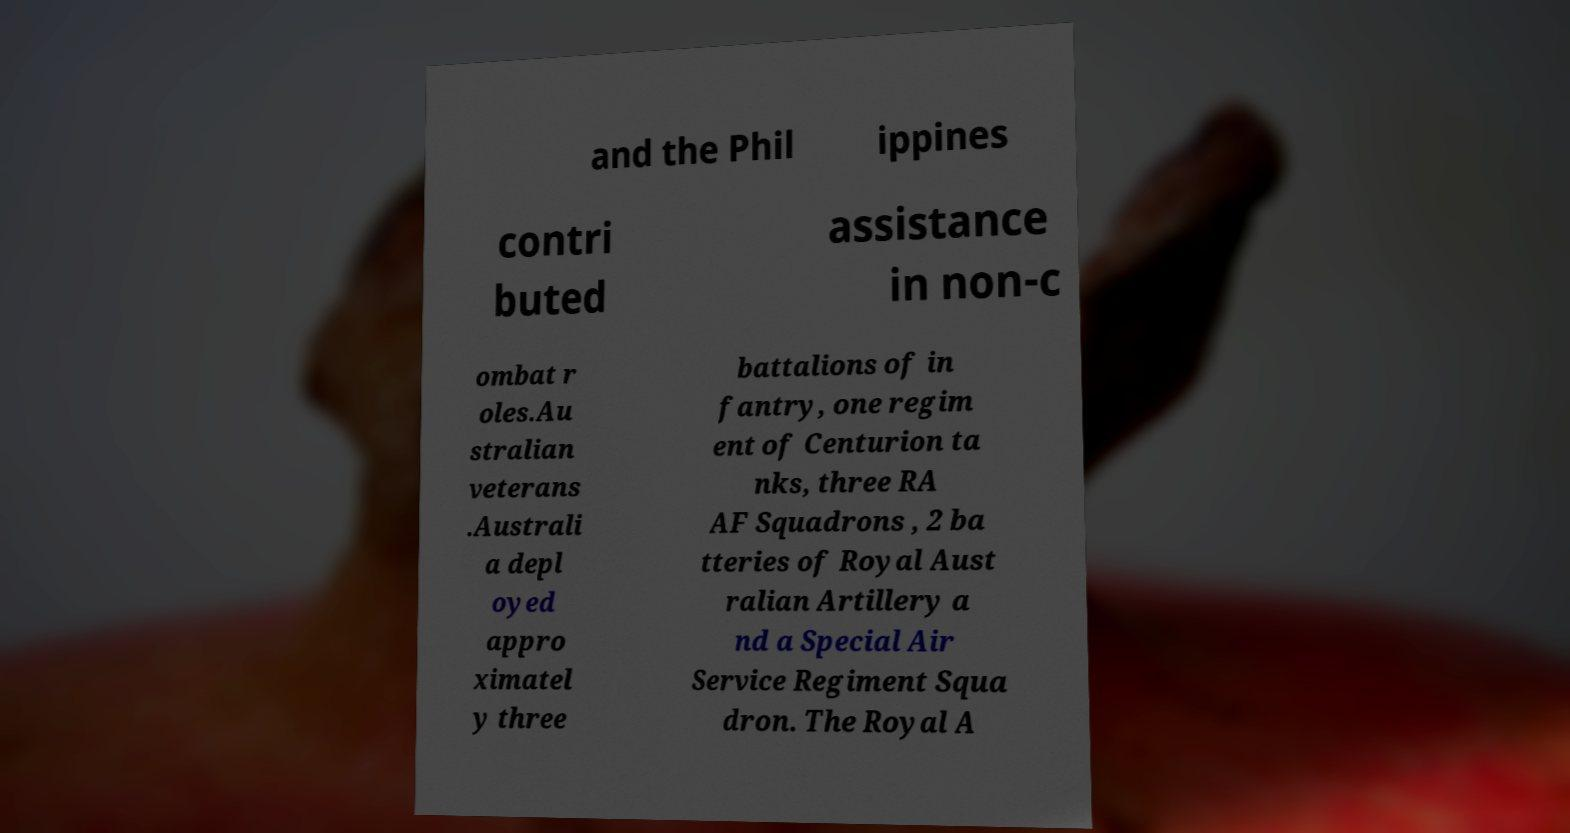Please read and relay the text visible in this image. What does it say? and the Phil ippines contri buted assistance in non-c ombat r oles.Au stralian veterans .Australi a depl oyed appro ximatel y three battalions of in fantry, one regim ent of Centurion ta nks, three RA AF Squadrons , 2 ba tteries of Royal Aust ralian Artillery a nd a Special Air Service Regiment Squa dron. The Royal A 